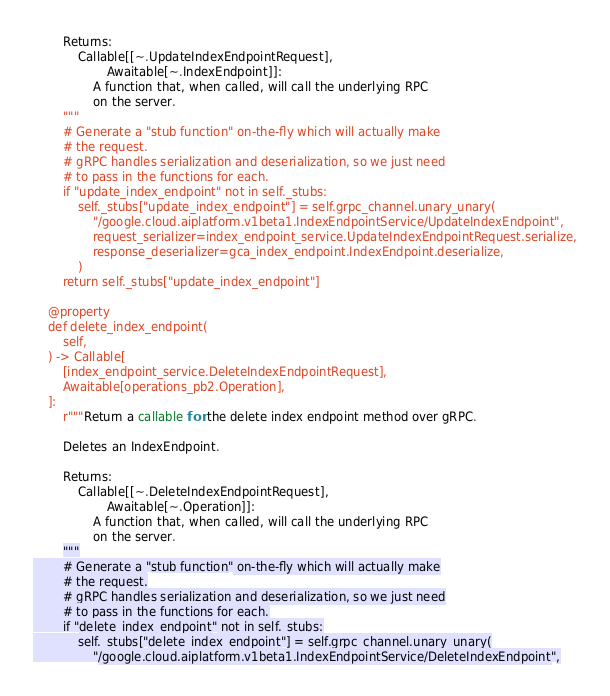Convert code to text. <code><loc_0><loc_0><loc_500><loc_500><_Python_>
        Returns:
            Callable[[~.UpdateIndexEndpointRequest],
                    Awaitable[~.IndexEndpoint]]:
                A function that, when called, will call the underlying RPC
                on the server.
        """
        # Generate a "stub function" on-the-fly which will actually make
        # the request.
        # gRPC handles serialization and deserialization, so we just need
        # to pass in the functions for each.
        if "update_index_endpoint" not in self._stubs:
            self._stubs["update_index_endpoint"] = self.grpc_channel.unary_unary(
                "/google.cloud.aiplatform.v1beta1.IndexEndpointService/UpdateIndexEndpoint",
                request_serializer=index_endpoint_service.UpdateIndexEndpointRequest.serialize,
                response_deserializer=gca_index_endpoint.IndexEndpoint.deserialize,
            )
        return self._stubs["update_index_endpoint"]

    @property
    def delete_index_endpoint(
        self,
    ) -> Callable[
        [index_endpoint_service.DeleteIndexEndpointRequest],
        Awaitable[operations_pb2.Operation],
    ]:
        r"""Return a callable for the delete index endpoint method over gRPC.

        Deletes an IndexEndpoint.

        Returns:
            Callable[[~.DeleteIndexEndpointRequest],
                    Awaitable[~.Operation]]:
                A function that, when called, will call the underlying RPC
                on the server.
        """
        # Generate a "stub function" on-the-fly which will actually make
        # the request.
        # gRPC handles serialization and deserialization, so we just need
        # to pass in the functions for each.
        if "delete_index_endpoint" not in self._stubs:
            self._stubs["delete_index_endpoint"] = self.grpc_channel.unary_unary(
                "/google.cloud.aiplatform.v1beta1.IndexEndpointService/DeleteIndexEndpoint",</code> 